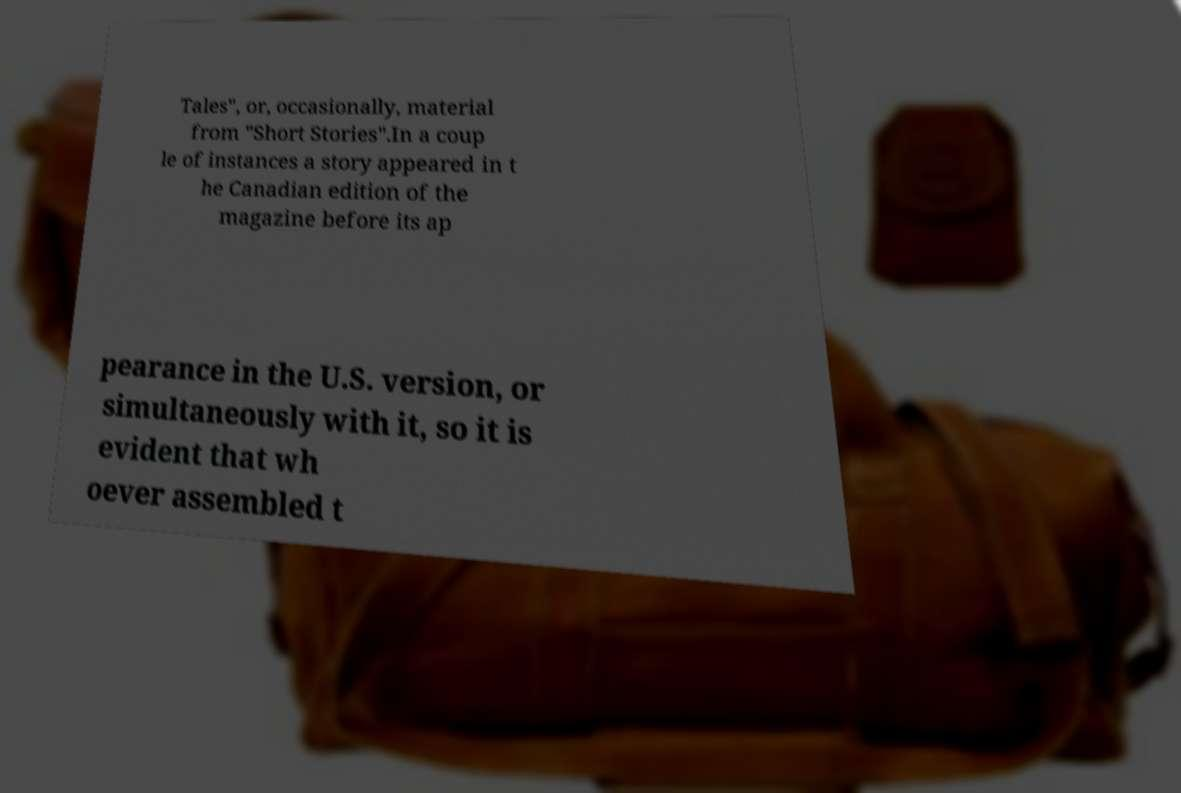For documentation purposes, I need the text within this image transcribed. Could you provide that? Tales", or, occasionally, material from "Short Stories".In a coup le of instances a story appeared in t he Canadian edition of the magazine before its ap pearance in the U.S. version, or simultaneously with it, so it is evident that wh oever assembled t 